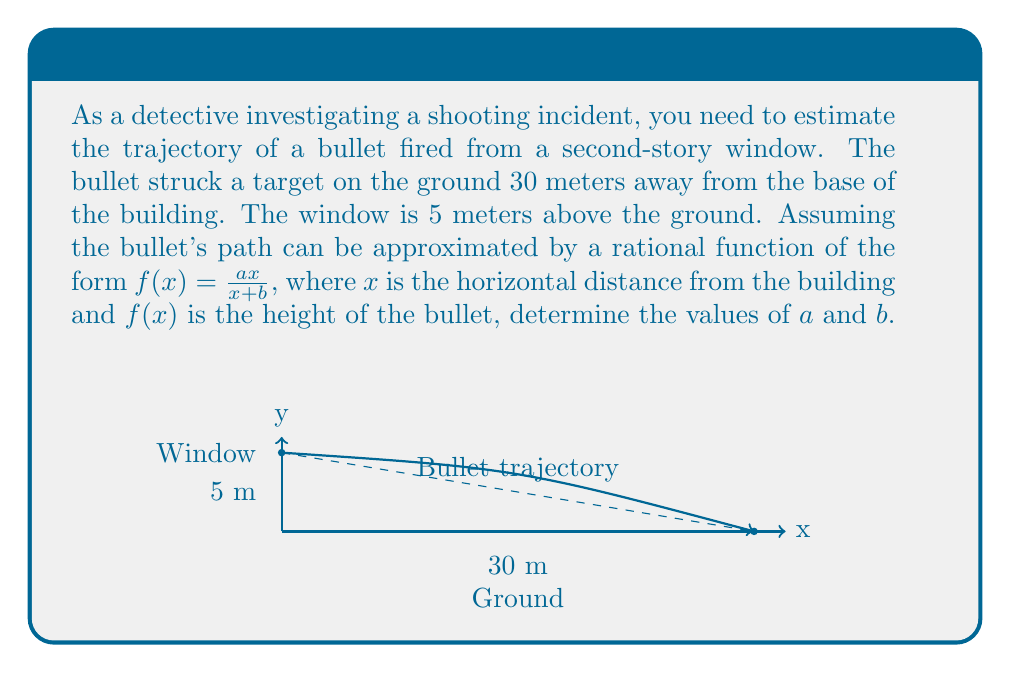Solve this math problem. To solve this problem, we'll follow these steps:

1) The rational function $f(x) = \frac{ax}{x+b}$ must satisfy two conditions:
   - When $x = 0$, $f(0) = 5$ (the bullet starts at 5 meters high)
   - When $x = 30$, $f(30) = 0$ (the bullet hits the ground 30 meters away)

2) Let's apply the first condition:
   $f(0) = \frac{a(0)}{0+b} = \frac{0}{b} = 5$
   This is only true if $b = 0$, but $b$ cannot be zero as it would make the denominator zero for $x = 0$. So this form of the function doesn't work exactly at $x = 0$.

3) We can, however, use the limit as $x$ approaches 0:
   $\lim_{x \to 0} \frac{ax}{x+b} = \frac{a}{1} = a = 5$
   So we know that $a = 5$.

4) Now let's apply the second condition:
   $f(30) = \frac{5(30)}{30+b} = 0$

5) Solve this equation:
   $\frac{150}{30+b} = 0$
   This is only true if the numerator is 0, which it isn't, or if the denominator approaches infinity. Since we can't have infinite $b$, this function doesn't perfectly model the situation at $x = 30$.

6) However, we can get very close to 0 with a large $b$. Let's choose $b = 150$. This gives:
   $f(30) = \frac{5(30)}{30+150} = \frac{150}{180} = \frac{5}{6} \approx 0.833$ meters

This is very close to the ground and provides a good approximation of the trajectory.

Therefore, a good approximation of the bullet's trajectory is given by:

$$f(x) = \frac{5x}{x+150}$$
Answer: $a = 5$, $b = 150$ 